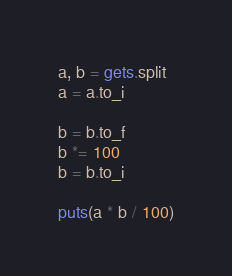Convert code to text. <code><loc_0><loc_0><loc_500><loc_500><_Ruby_>a, b = gets.split
a = a.to_i

b = b.to_f
b *= 100
b = b.to_i

puts(a * b / 100)
</code> 